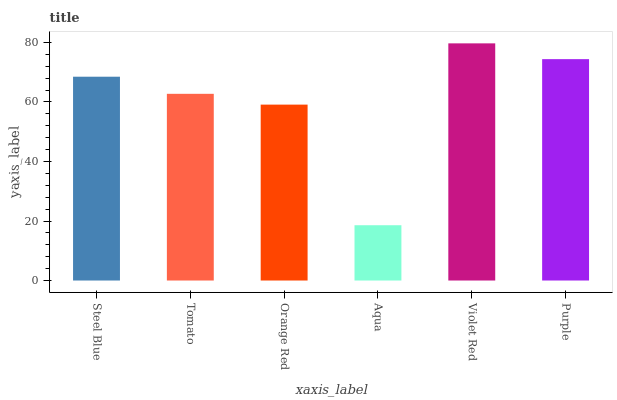Is Aqua the minimum?
Answer yes or no. Yes. Is Violet Red the maximum?
Answer yes or no. Yes. Is Tomato the minimum?
Answer yes or no. No. Is Tomato the maximum?
Answer yes or no. No. Is Steel Blue greater than Tomato?
Answer yes or no. Yes. Is Tomato less than Steel Blue?
Answer yes or no. Yes. Is Tomato greater than Steel Blue?
Answer yes or no. No. Is Steel Blue less than Tomato?
Answer yes or no. No. Is Steel Blue the high median?
Answer yes or no. Yes. Is Tomato the low median?
Answer yes or no. Yes. Is Violet Red the high median?
Answer yes or no. No. Is Violet Red the low median?
Answer yes or no. No. 